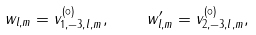<formula> <loc_0><loc_0><loc_500><loc_500>w _ { l , m } = v ^ { ( \circ ) } _ { 1 , - 3 , l , m } , \quad w ^ { \prime } _ { l , m } = v ^ { ( \circ ) } _ { 2 , - 3 , l , m } ,</formula> 